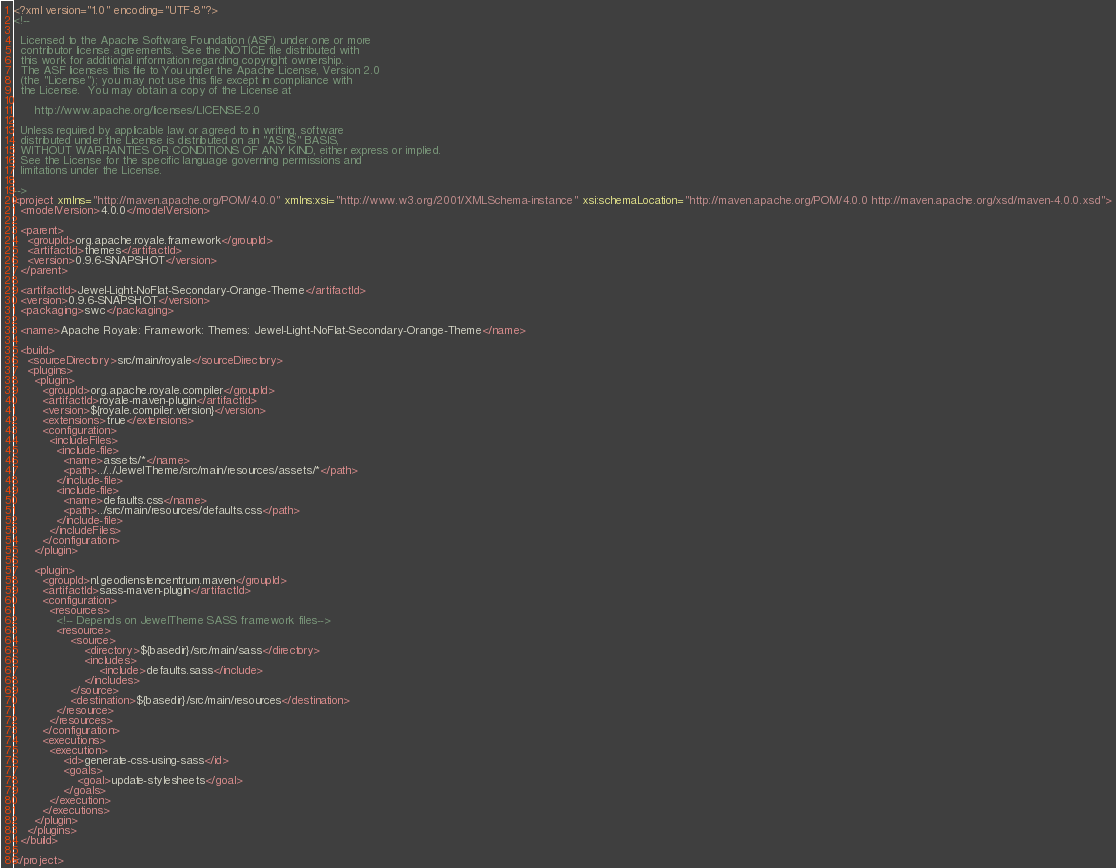<code> <loc_0><loc_0><loc_500><loc_500><_XML_><?xml version="1.0" encoding="UTF-8"?>
<!--

  Licensed to the Apache Software Foundation (ASF) under one or more
  contributor license agreements.  See the NOTICE file distributed with
  this work for additional information regarding copyright ownership.
  The ASF licenses this file to You under the Apache License, Version 2.0
  (the "License"); you may not use this file except in compliance with
  the License.  You may obtain a copy of the License at

      http://www.apache.org/licenses/LICENSE-2.0

  Unless required by applicable law or agreed to in writing, software
  distributed under the License is distributed on an "AS IS" BASIS,
  WITHOUT WARRANTIES OR CONDITIONS OF ANY KIND, either express or implied.
  See the License for the specific language governing permissions and
  limitations under the License.

-->
<project xmlns="http://maven.apache.org/POM/4.0.0" xmlns:xsi="http://www.w3.org/2001/XMLSchema-instance" xsi:schemaLocation="http://maven.apache.org/POM/4.0.0 http://maven.apache.org/xsd/maven-4.0.0.xsd">
  <modelVersion>4.0.0</modelVersion>

  <parent>
    <groupId>org.apache.royale.framework</groupId>
    <artifactId>themes</artifactId>
    <version>0.9.6-SNAPSHOT</version>
  </parent>

  <artifactId>Jewel-Light-NoFlat-Secondary-Orange-Theme</artifactId>
  <version>0.9.6-SNAPSHOT</version>
  <packaging>swc</packaging>

  <name>Apache Royale: Framework: Themes: Jewel-Light-NoFlat-Secondary-Orange-Theme</name>

  <build>
    <sourceDirectory>src/main/royale</sourceDirectory>
    <plugins>
      <plugin>
        <groupId>org.apache.royale.compiler</groupId>
        <artifactId>royale-maven-plugin</artifactId>
        <version>${royale.compiler.version}</version>
        <extensions>true</extensions>
        <configuration>
          <includeFiles>
            <include-file>
              <name>assets/*</name>
              <path>../../JewelTheme/src/main/resources/assets/*</path>
            </include-file>
            <include-file>
              <name>defaults.css</name>
              <path>../src/main/resources/defaults.css</path>
            </include-file>
          </includeFiles>
        </configuration>
      </plugin>

      <plugin>
        <groupId>nl.geodienstencentrum.maven</groupId>
        <artifactId>sass-maven-plugin</artifactId>
        <configuration>
          <resources>
            <!-- Depends on JewelTheme SASS framework files-->
            <resource>
                <source>
                    <directory>${basedir}/src/main/sass</directory>
                    <includes>
                        <include>defaults.sass</include>
                    </includes>
                </source>
                <destination>${basedir}/src/main/resources</destination>
            </resource>
          </resources>
        </configuration>
        <executions>
          <execution>
              <id>generate-css-using-sass</id>
              <goals>
                  <goal>update-stylesheets</goal>
              </goals>
          </execution>
        </executions>
      </plugin>
    </plugins>
  </build>

</project>
</code> 